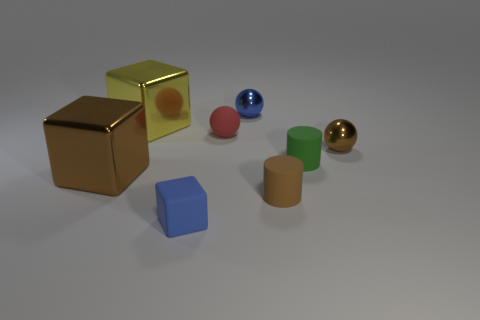Add 2 tiny rubber spheres. How many objects exist? 10 Subtract all blocks. How many objects are left? 5 Subtract all small rubber blocks. Subtract all large metal objects. How many objects are left? 5 Add 8 small red matte things. How many small red matte things are left? 9 Add 2 gray rubber objects. How many gray rubber objects exist? 2 Subtract 1 brown cylinders. How many objects are left? 7 